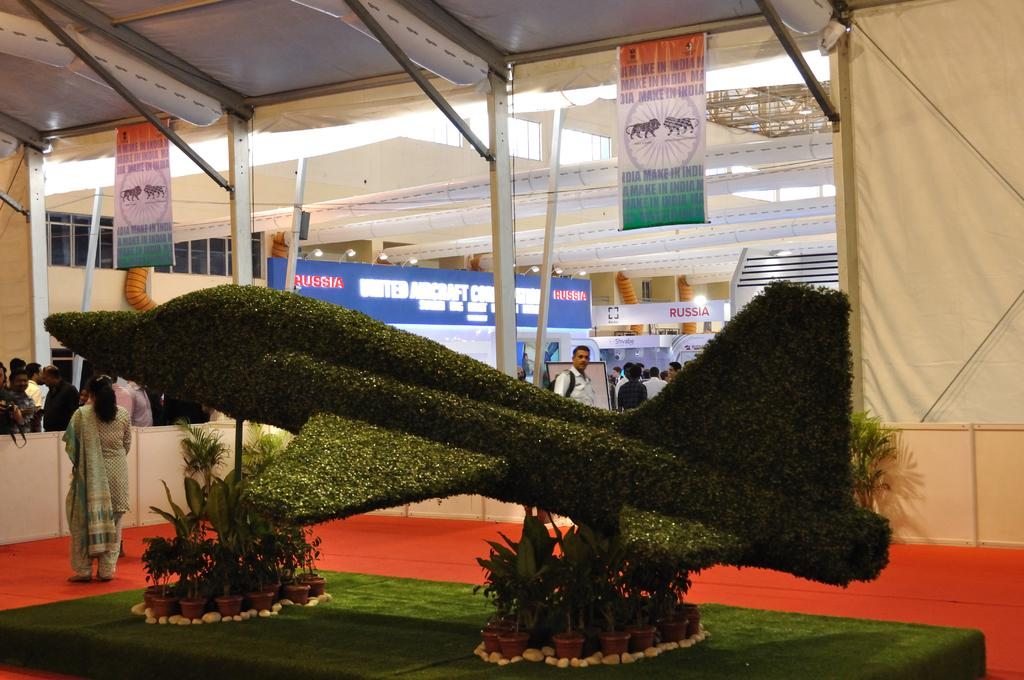What is the main subject in the center of the image? There is a grass statue in the center of the image. What other objects can be seen in the image? There are pots in the image. What can be seen in the background of the image? There are people, at least one building, hoardings, and posters in the background of the image. What type of weather can be seen in the image? The image does not provide information about the weather, as it focuses on the grass statue, pots, and the background elements. 